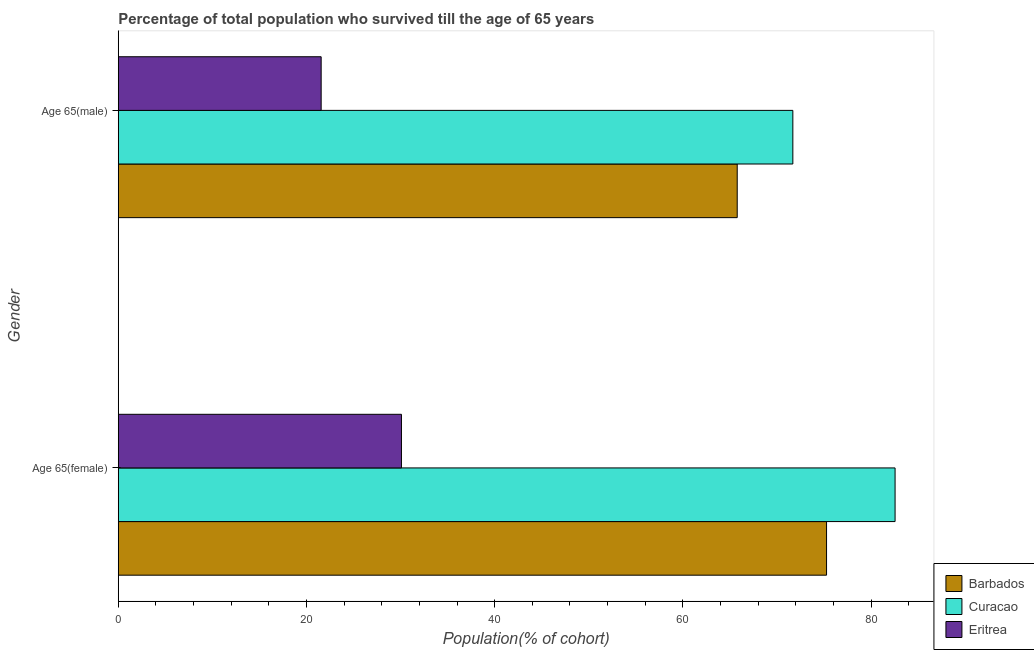How many different coloured bars are there?
Your answer should be compact. 3. How many groups of bars are there?
Your answer should be very brief. 2. How many bars are there on the 1st tick from the top?
Your answer should be very brief. 3. What is the label of the 1st group of bars from the top?
Provide a succinct answer. Age 65(male). What is the percentage of male population who survived till age of 65 in Eritrea?
Provide a succinct answer. 21.56. Across all countries, what is the maximum percentage of female population who survived till age of 65?
Your answer should be very brief. 82.56. Across all countries, what is the minimum percentage of male population who survived till age of 65?
Provide a short and direct response. 21.56. In which country was the percentage of male population who survived till age of 65 maximum?
Provide a short and direct response. Curacao. In which country was the percentage of female population who survived till age of 65 minimum?
Provide a succinct answer. Eritrea. What is the total percentage of female population who survived till age of 65 in the graph?
Your answer should be very brief. 187.93. What is the difference between the percentage of male population who survived till age of 65 in Curacao and that in Eritrea?
Your answer should be very brief. 50.13. What is the difference between the percentage of male population who survived till age of 65 in Barbados and the percentage of female population who survived till age of 65 in Eritrea?
Your response must be concise. 35.68. What is the average percentage of male population who survived till age of 65 per country?
Keep it short and to the point. 53.01. What is the difference between the percentage of male population who survived till age of 65 and percentage of female population who survived till age of 65 in Eritrea?
Offer a very short reply. -8.53. What is the ratio of the percentage of female population who survived till age of 65 in Curacao to that in Eritrea?
Offer a very short reply. 2.74. In how many countries, is the percentage of female population who survived till age of 65 greater than the average percentage of female population who survived till age of 65 taken over all countries?
Keep it short and to the point. 2. What does the 3rd bar from the top in Age 65(male) represents?
Your answer should be very brief. Barbados. What does the 3rd bar from the bottom in Age 65(male) represents?
Give a very brief answer. Eritrea. Are all the bars in the graph horizontal?
Your answer should be compact. Yes. What is the difference between two consecutive major ticks on the X-axis?
Offer a very short reply. 20. Are the values on the major ticks of X-axis written in scientific E-notation?
Your answer should be very brief. No. Does the graph contain grids?
Provide a short and direct response. No. Where does the legend appear in the graph?
Provide a short and direct response. Bottom right. How many legend labels are there?
Your response must be concise. 3. What is the title of the graph?
Your answer should be compact. Percentage of total population who survived till the age of 65 years. Does "Bhutan" appear as one of the legend labels in the graph?
Provide a short and direct response. No. What is the label or title of the X-axis?
Give a very brief answer. Population(% of cohort). What is the label or title of the Y-axis?
Offer a very short reply. Gender. What is the Population(% of cohort) in Barbados in Age 65(female)?
Your answer should be compact. 75.28. What is the Population(% of cohort) of Curacao in Age 65(female)?
Give a very brief answer. 82.56. What is the Population(% of cohort) of Eritrea in Age 65(female)?
Ensure brevity in your answer.  30.1. What is the Population(% of cohort) of Barbados in Age 65(male)?
Provide a succinct answer. 65.78. What is the Population(% of cohort) of Curacao in Age 65(male)?
Keep it short and to the point. 71.69. What is the Population(% of cohort) of Eritrea in Age 65(male)?
Offer a very short reply. 21.56. Across all Gender, what is the maximum Population(% of cohort) in Barbados?
Give a very brief answer. 75.28. Across all Gender, what is the maximum Population(% of cohort) of Curacao?
Offer a very short reply. 82.56. Across all Gender, what is the maximum Population(% of cohort) of Eritrea?
Your response must be concise. 30.1. Across all Gender, what is the minimum Population(% of cohort) in Barbados?
Your answer should be compact. 65.78. Across all Gender, what is the minimum Population(% of cohort) of Curacao?
Ensure brevity in your answer.  71.69. Across all Gender, what is the minimum Population(% of cohort) in Eritrea?
Keep it short and to the point. 21.56. What is the total Population(% of cohort) of Barbados in the graph?
Offer a terse response. 141.06. What is the total Population(% of cohort) of Curacao in the graph?
Give a very brief answer. 154.25. What is the total Population(% of cohort) of Eritrea in the graph?
Provide a succinct answer. 51.66. What is the difference between the Population(% of cohort) of Barbados in Age 65(female) and that in Age 65(male)?
Make the answer very short. 9.49. What is the difference between the Population(% of cohort) of Curacao in Age 65(female) and that in Age 65(male)?
Keep it short and to the point. 10.87. What is the difference between the Population(% of cohort) in Eritrea in Age 65(female) and that in Age 65(male)?
Your answer should be very brief. 8.53. What is the difference between the Population(% of cohort) in Barbados in Age 65(female) and the Population(% of cohort) in Curacao in Age 65(male)?
Keep it short and to the point. 3.58. What is the difference between the Population(% of cohort) of Barbados in Age 65(female) and the Population(% of cohort) of Eritrea in Age 65(male)?
Make the answer very short. 53.71. What is the difference between the Population(% of cohort) in Curacao in Age 65(female) and the Population(% of cohort) in Eritrea in Age 65(male)?
Provide a succinct answer. 61. What is the average Population(% of cohort) of Barbados per Gender?
Your answer should be compact. 70.53. What is the average Population(% of cohort) of Curacao per Gender?
Ensure brevity in your answer.  77.13. What is the average Population(% of cohort) in Eritrea per Gender?
Give a very brief answer. 25.83. What is the difference between the Population(% of cohort) of Barbados and Population(% of cohort) of Curacao in Age 65(female)?
Give a very brief answer. -7.28. What is the difference between the Population(% of cohort) of Barbados and Population(% of cohort) of Eritrea in Age 65(female)?
Your answer should be compact. 45.18. What is the difference between the Population(% of cohort) of Curacao and Population(% of cohort) of Eritrea in Age 65(female)?
Provide a succinct answer. 52.46. What is the difference between the Population(% of cohort) in Barbados and Population(% of cohort) in Curacao in Age 65(male)?
Give a very brief answer. -5.91. What is the difference between the Population(% of cohort) of Barbados and Population(% of cohort) of Eritrea in Age 65(male)?
Provide a succinct answer. 44.22. What is the difference between the Population(% of cohort) of Curacao and Population(% of cohort) of Eritrea in Age 65(male)?
Make the answer very short. 50.13. What is the ratio of the Population(% of cohort) of Barbados in Age 65(female) to that in Age 65(male)?
Your answer should be compact. 1.14. What is the ratio of the Population(% of cohort) of Curacao in Age 65(female) to that in Age 65(male)?
Provide a succinct answer. 1.15. What is the ratio of the Population(% of cohort) of Eritrea in Age 65(female) to that in Age 65(male)?
Your response must be concise. 1.4. What is the difference between the highest and the second highest Population(% of cohort) in Barbados?
Give a very brief answer. 9.49. What is the difference between the highest and the second highest Population(% of cohort) in Curacao?
Give a very brief answer. 10.87. What is the difference between the highest and the second highest Population(% of cohort) of Eritrea?
Provide a succinct answer. 8.53. What is the difference between the highest and the lowest Population(% of cohort) of Barbados?
Offer a terse response. 9.49. What is the difference between the highest and the lowest Population(% of cohort) of Curacao?
Keep it short and to the point. 10.87. What is the difference between the highest and the lowest Population(% of cohort) in Eritrea?
Your answer should be compact. 8.53. 